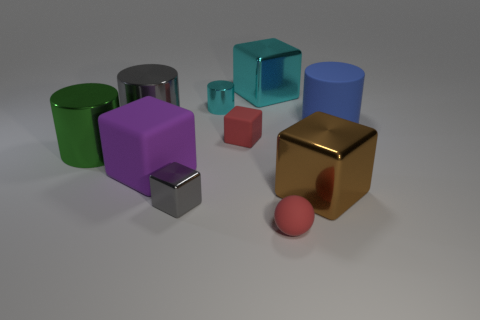Subtract all cyan cubes. How many cubes are left? 4 Subtract all tiny red rubber blocks. How many blocks are left? 4 Subtract all green cubes. Subtract all brown cylinders. How many cubes are left? 5 Subtract all cylinders. How many objects are left? 6 Subtract 0 brown cylinders. How many objects are left? 10 Subtract all purple rubber cubes. Subtract all blue things. How many objects are left? 8 Add 8 big shiny cylinders. How many big shiny cylinders are left? 10 Add 8 green cylinders. How many green cylinders exist? 9 